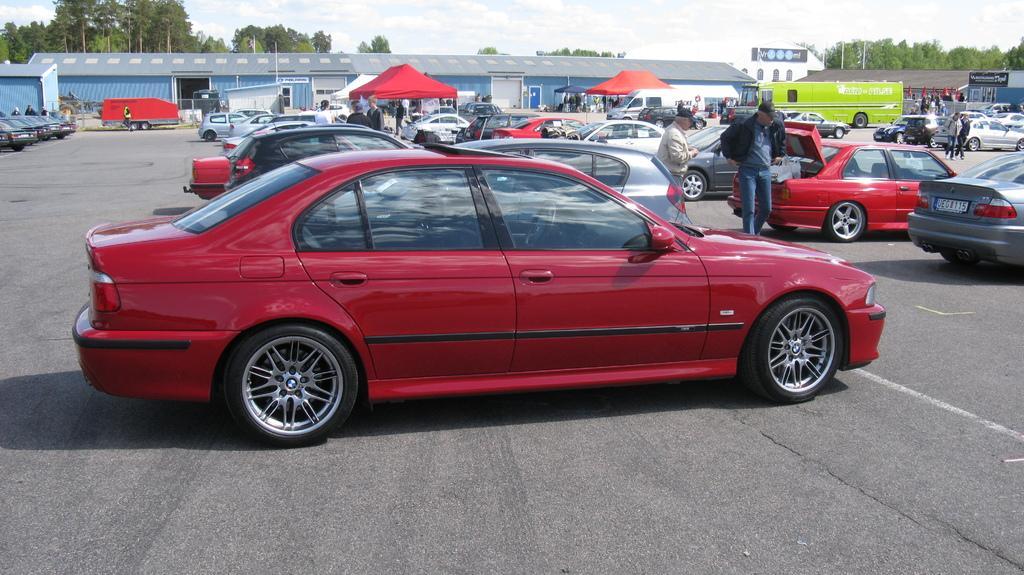Can you describe this image briefly? In this image, we can see sheds, tents, people, vehicles, flags and some other objects are on the road. In the background, there are trees and at the top, there are clouds in the sky. 